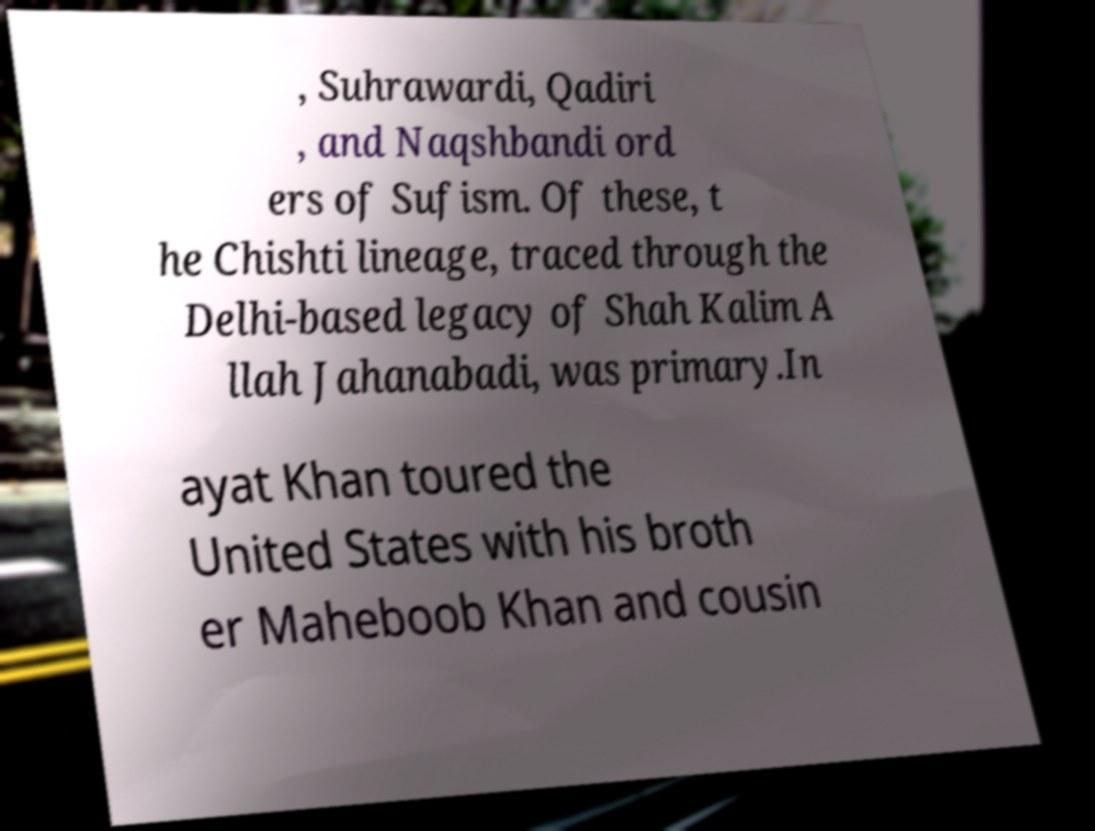Please identify and transcribe the text found in this image. , Suhrawardi, Qadiri , and Naqshbandi ord ers of Sufism. Of these, t he Chishti lineage, traced through the Delhi-based legacy of Shah Kalim A llah Jahanabadi, was primary.In ayat Khan toured the United States with his broth er Maheboob Khan and cousin 